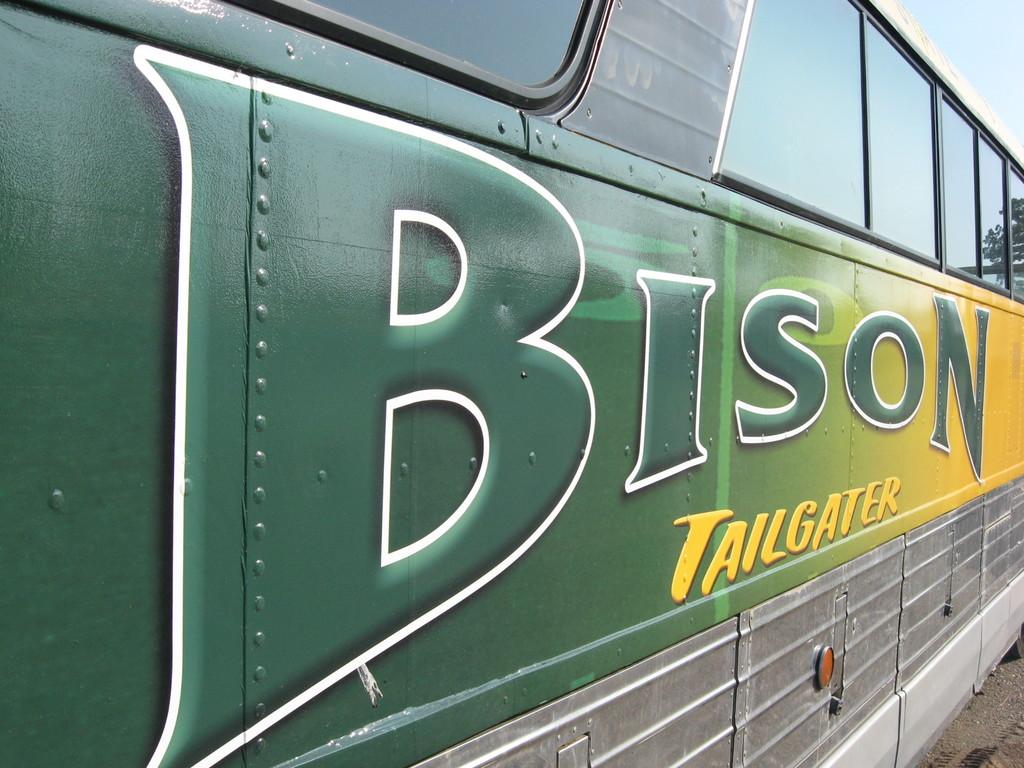What is the name of the tailgater?
Your response must be concise. Bison. What is written in all yellow?
Offer a terse response. Tailgater. 